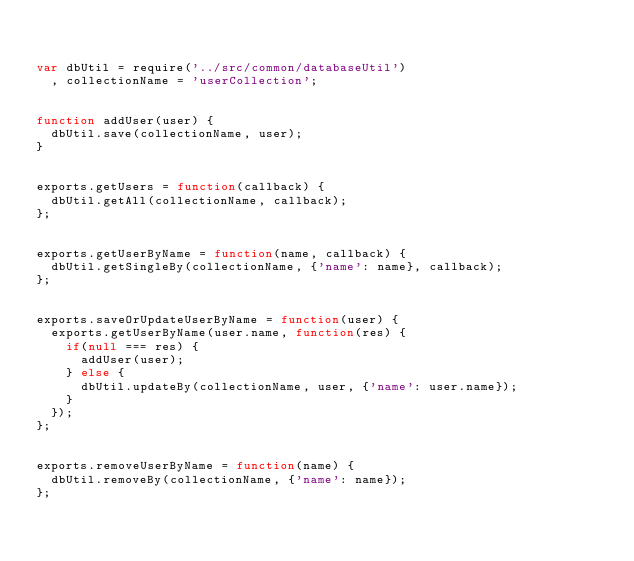Convert code to text. <code><loc_0><loc_0><loc_500><loc_500><_JavaScript_>

var dbUtil = require('../src/common/databaseUtil')
	, collectionName = 'userCollection';


function addUser(user) {
	dbUtil.save(collectionName, user);
}


exports.getUsers = function(callback) {
	dbUtil.getAll(collectionName, callback);
};


exports.getUserByName = function(name, callback) {
	dbUtil.getSingleBy(collectionName, {'name': name}, callback);
};


exports.saveOrUpdateUserByName = function(user) {
	exports.getUserByName(user.name, function(res) {
		if(null === res) {
			addUser(user);
		} else {
			dbUtil.updateBy(collectionName, user, {'name': user.name});
		}
	});
};


exports.removeUserByName = function(name) {
	dbUtil.removeBy(collectionName, {'name': name});
};

</code> 